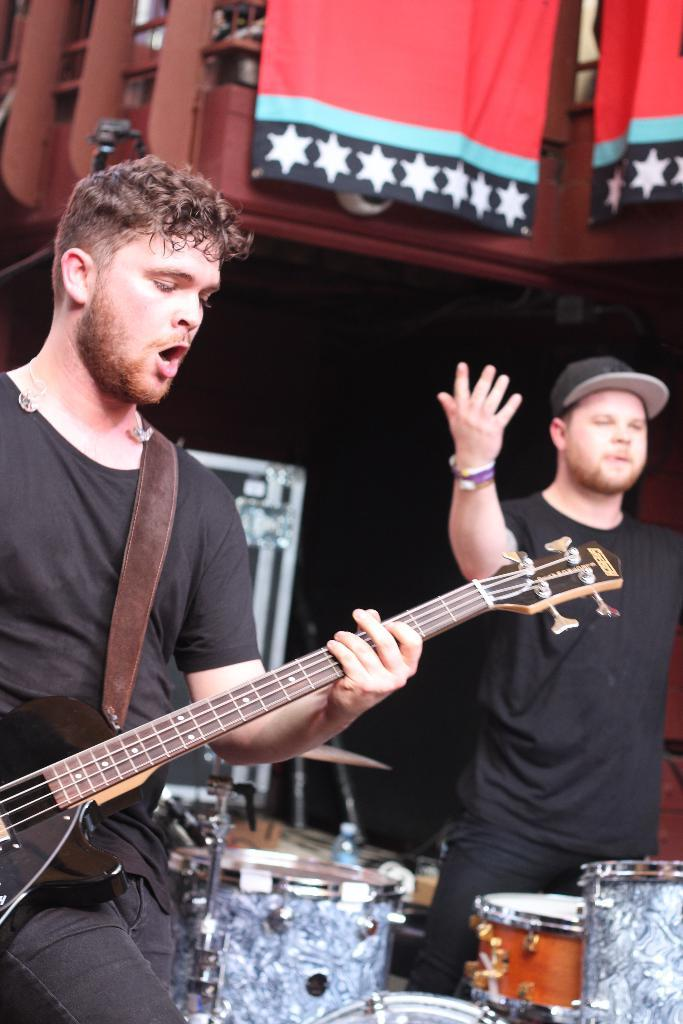How many people are in the image? There are two people standing in the image. What is the man doing in the image? The man is playing a guitar. What other objects are present in the image besides the people? There are musical instruments in the image. What can be seen in the background of the image? The background of the image is dark, and there are flags visible. Are there any pets visible in the image? No, there are no pets present in the image. What type of board is being used for the event in the image? There is no event or board present in the image. 